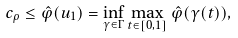<formula> <loc_0><loc_0><loc_500><loc_500>c _ { \rho } \leq \hat { \varphi } ( u _ { 1 } ) = \inf _ { \gamma \in \Gamma } \max _ { t \in [ 0 , 1 ] } \hat { \varphi } ( \gamma ( t ) ) ,</formula> 